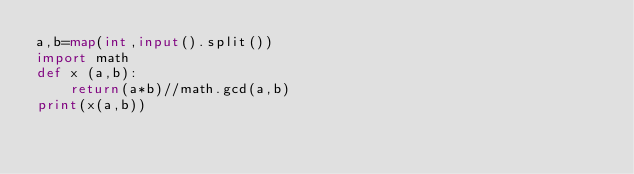Convert code to text. <code><loc_0><loc_0><loc_500><loc_500><_Python_>a,b=map(int,input().split())
import math
def x (a,b):
    return(a*b)//math.gcd(a,b)
print(x(a,b))
</code> 